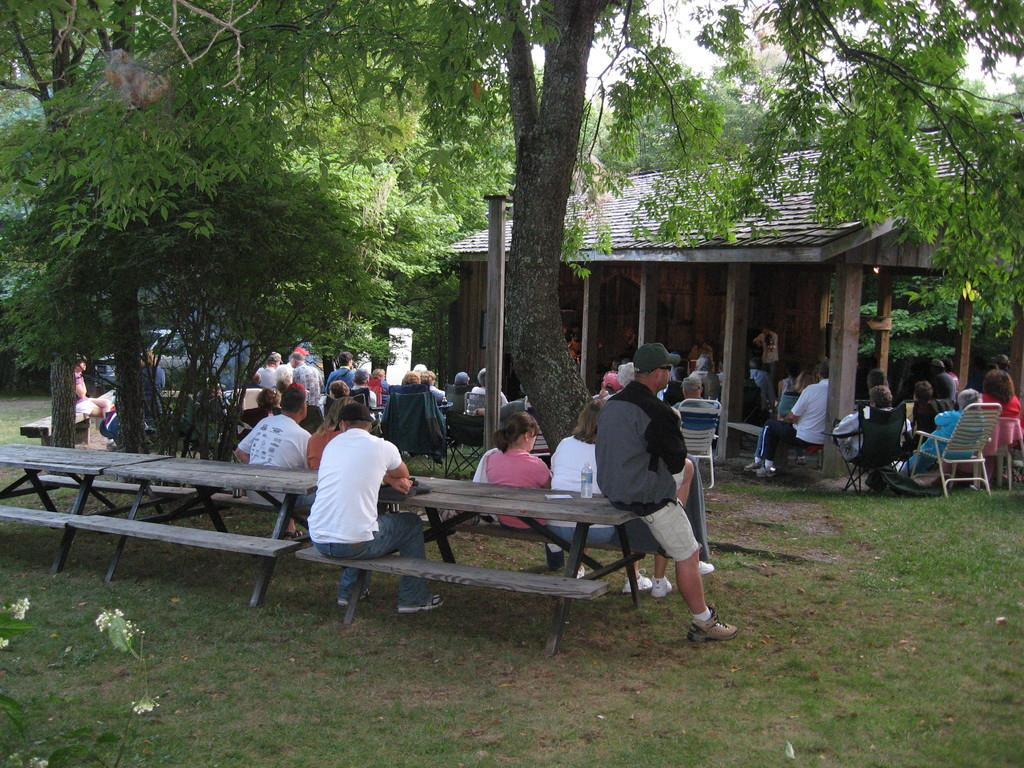Who or what can be seen in the image? There are people in the image. What type of structure is visible in the image? There is a house in the image. What type of seating is available in the image? There are benches and chairs in the image. What type of natural environment is present in the image? Grass and trees are present in the image. Can you see any fish swimming in the grass in the image? There are no fish present in the image, and the grass is not a body of water where fish would swim. 